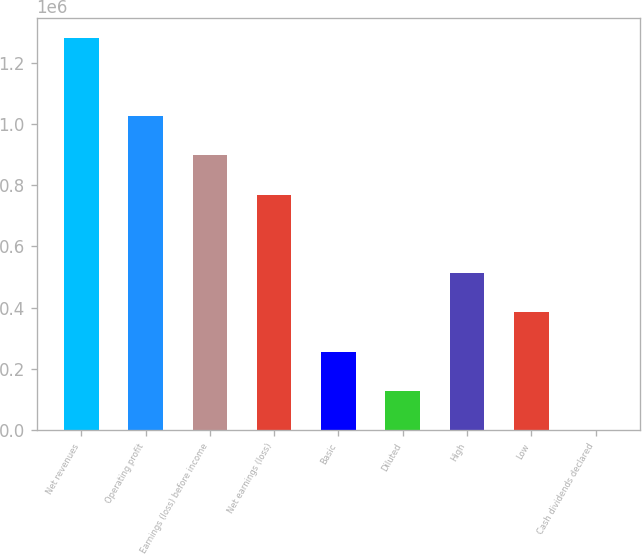Convert chart. <chart><loc_0><loc_0><loc_500><loc_500><bar_chart><fcel>Net revenues<fcel>Operating profit<fcel>Earnings (loss) before income<fcel>Net earnings (loss)<fcel>Basic<fcel>Diluted<fcel>High<fcel>Low<fcel>Cash dividends declared<nl><fcel>1.28177e+06<fcel>1.02542e+06<fcel>897241<fcel>769064<fcel>256355<fcel>128178<fcel>512709<fcel>384532<fcel>0.4<nl></chart> 